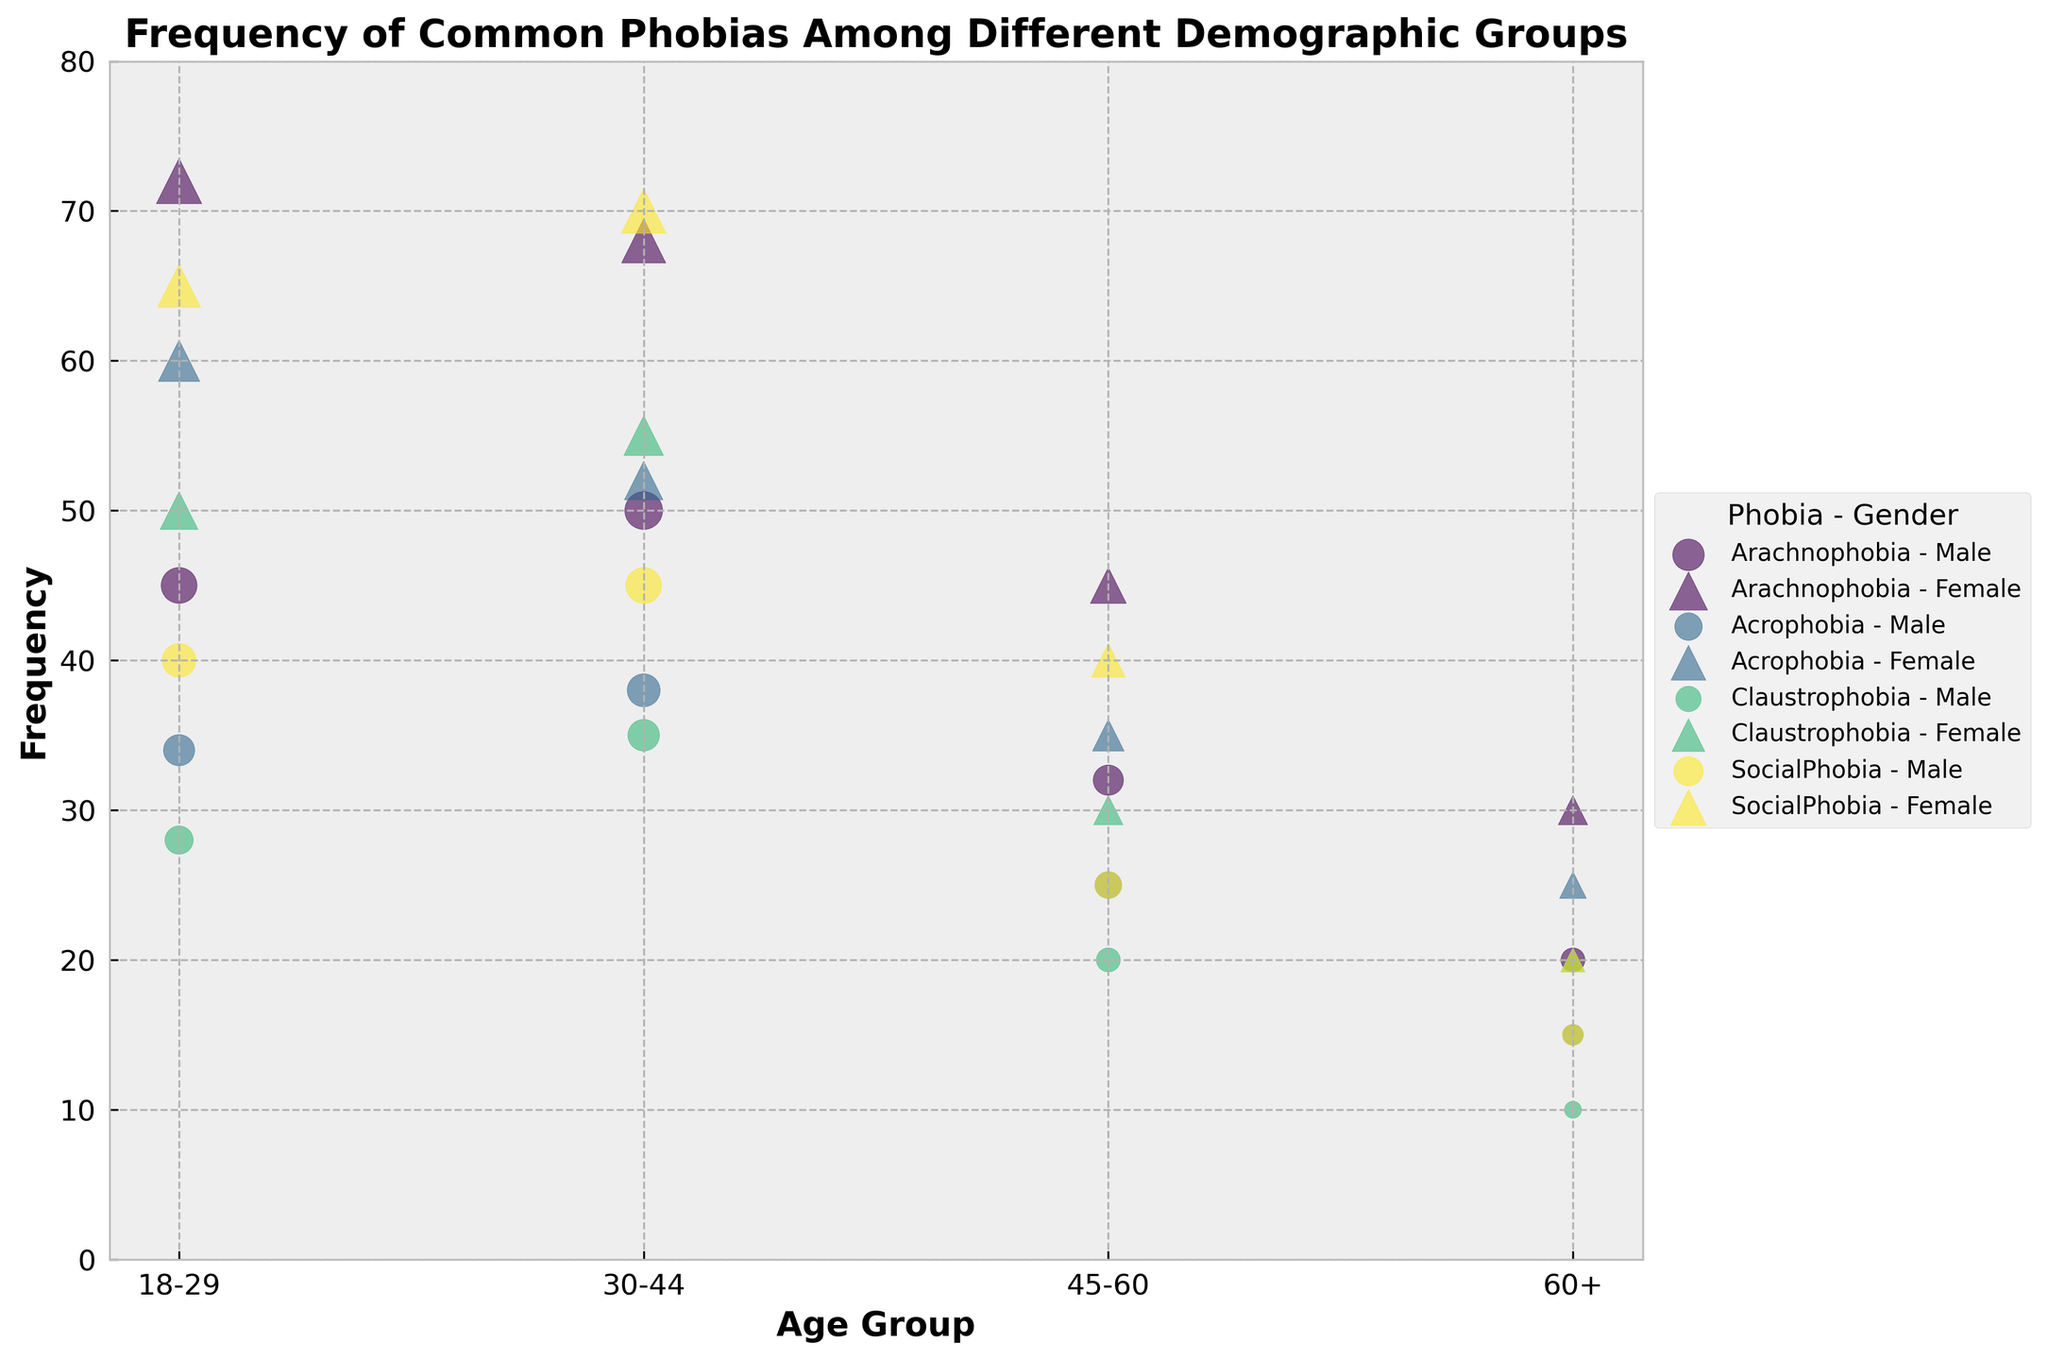What's the title of this figure? The title is located at the top of the figure and specifically describes the subject matter. It reads "Frequency of Common Phobias Among Different Demographic Groups".
Answer: Frequency of Common Phobias Among Different Demographic Groups How does the frequency of Arachnophobia for females aged 18-29 compare to males of the same age group? Locate the data points for Arachnophobia in the age group 18-29. For males, the bubble is lower and smaller (at y=45), while for females, the bubble is higher and larger (at y=72). Therefore, the frequency for females is higher than males.
Answer: Higher Which phobia shows the lowest frequency among the 60+ age group for both genders combined? Scan the chart for each phobia and identify the bubbles corresponding to the 60+ age group. Acrophobia has the lowest bubbles at 15 (male) and 25 (female), giving a total frequency of 40. None of the other phobias (Arachnophobia, Claustrophobia, SocialPhobia) have combined frequencies lower than 40.
Answer: Acrophobia What is the overall trend in SocialPhobia frequencies across age groups for both genders? Look at the positions of the bubbles for SocialPhobia across age groups for both genders. The bubbles decrease in size and height as the age group increases, indicating a downward trend in frequency with increasing age.
Answer: Decreasing Which phobia has the highest recorded frequency, and in which demographic group does it occur? Identify the largest bubbles across the chart. The largest bubble corresponds to SocialPhobia in females aged 30-44, which is the highest recorded frequency at y=70.
Answer: SocialPhobia in females aged 30-44 Between Claustrophobia for females in the 30-44 age group and males in the 18-29 age group, which has the higher frequency? Compare the positions of the bubbles for Claustrophobia in these two demographics. For females aged 30-44, the bubble is at y=55, while for males aged 18-29, it is at y=28. Therefore, females in the 30-44 age group have a higher frequency.
Answer: Females aged 30-44 How does the average frequency of Acrophobia compare between males and females? Calculate the average for each gender by summing their frequencies across age groups and then dividing by the number of age groups. Males: (34 + 38 + 25 + 15)/4 = 112/4 = 28, Females: (60 + 52 + 35 + 25)/4 = 172/4 = 43. Hence, the average frequency is higher for females.
Answer: Higher for females Which age group shows the most significant gender difference for SocialPhobia, and what are the respective frequencies? Compare the differences between male and female frequencies across all age groups for SocialPhobia. The largest difference is in the 30-44 age group with frequencies of 45 (male) and 70 (female). The difference is 25.
Answer: 30-44, Males: 45, Females: 70 What shape and color are used to represent Acrophobia in females? Each combination of phobia and gender is uniquely marked. Acrophobia in females is marked with triangles (^) and the respective color from the viridis colormap. Specifically, look for triangles within the Acrophobia segment of the color gradient.
Answer: Triangles in a viridis colormap shade For Arachnophobia, infer the approximate bubble size ratio between males aged 18-29 and males aged 60+. The size of the bubbles is based on the frequency. For males aged 18-29, the frequency is 45, and for males aged 60+, it is 20. Therefore, the approximate ratio of the bubble sizes is 45:20 or simplified to 9:4.
Answer: 9:4 